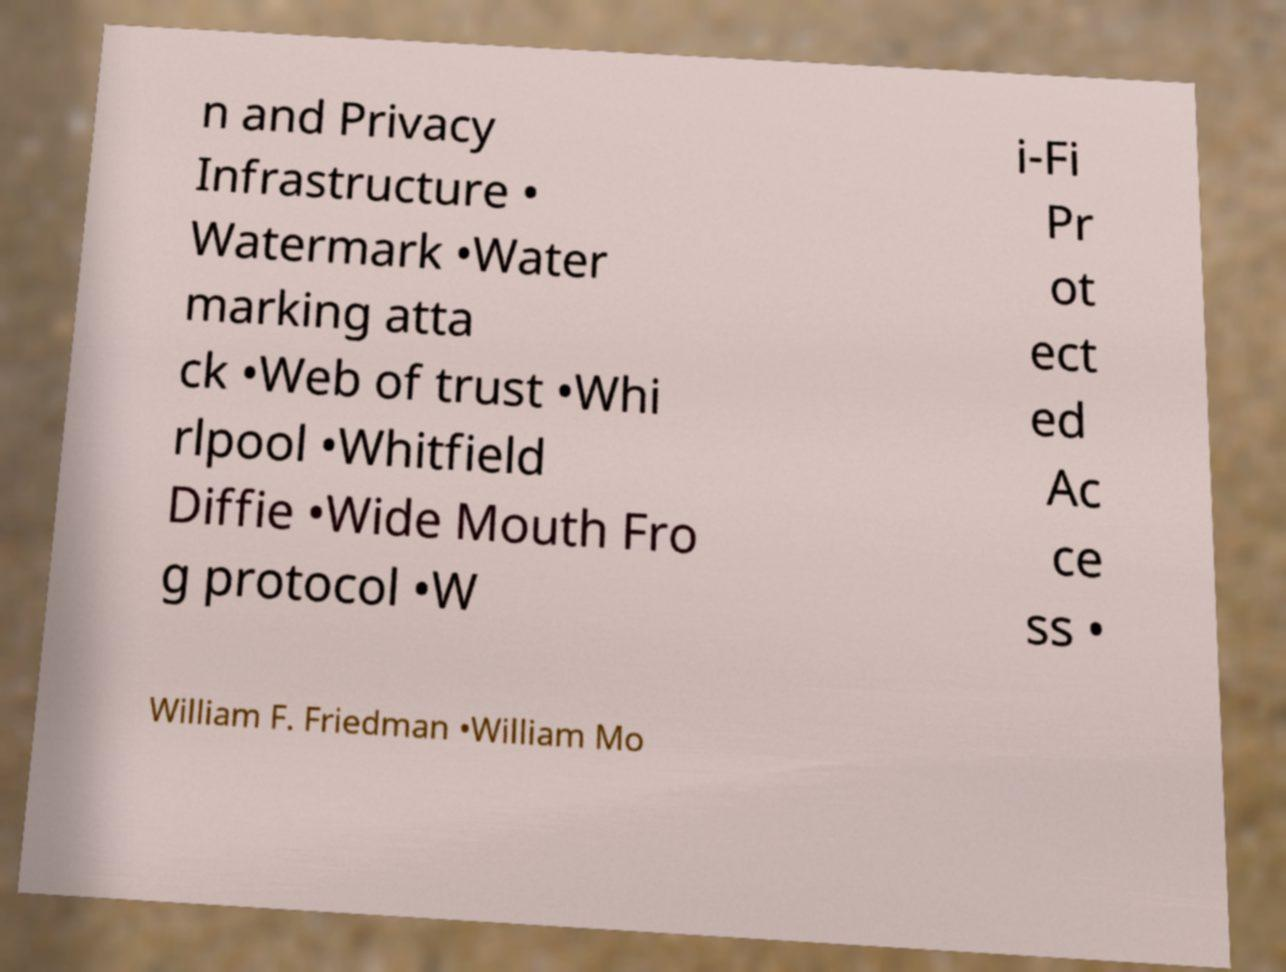There's text embedded in this image that I need extracted. Can you transcribe it verbatim? n and Privacy Infrastructure • Watermark •Water marking atta ck •Web of trust •Whi rlpool •Whitfield Diffie •Wide Mouth Fro g protocol •W i-Fi Pr ot ect ed Ac ce ss • William F. Friedman •William Mo 